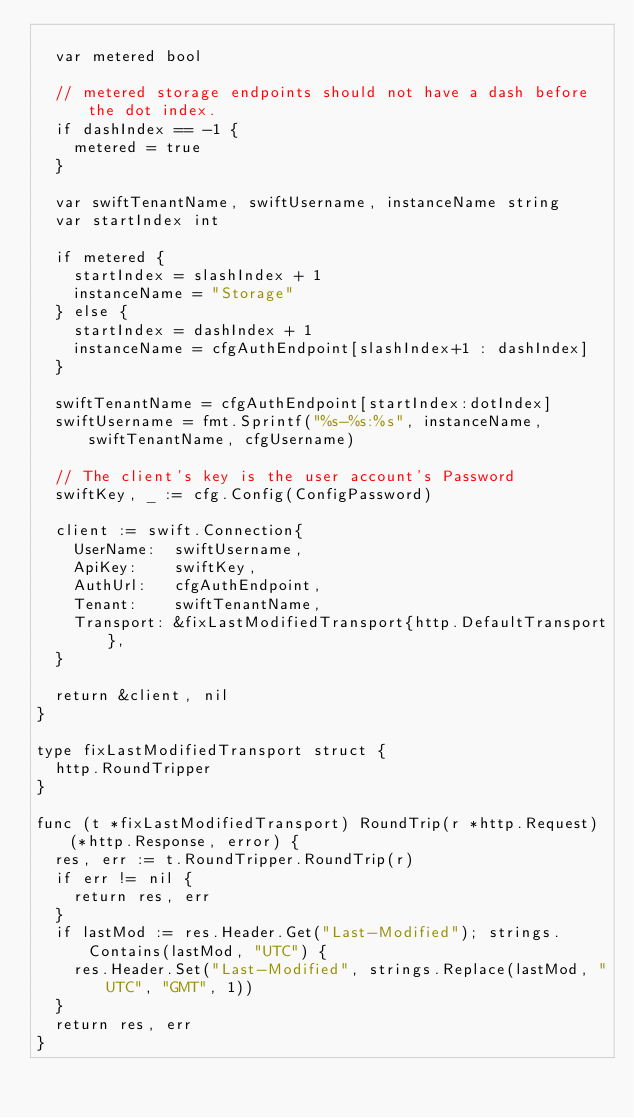Convert code to text. <code><loc_0><loc_0><loc_500><loc_500><_Go_>
	var metered bool

	// metered storage endpoints should not have a dash before the dot index.
	if dashIndex == -1 {
		metered = true
	}

	var swiftTenantName, swiftUsername, instanceName string
	var startIndex int

	if metered {
		startIndex = slashIndex + 1
		instanceName = "Storage"
	} else {
		startIndex = dashIndex + 1
		instanceName = cfgAuthEndpoint[slashIndex+1 : dashIndex]
	}

	swiftTenantName = cfgAuthEndpoint[startIndex:dotIndex]
	swiftUsername = fmt.Sprintf("%s-%s:%s", instanceName, swiftTenantName, cfgUsername)

	// The client's key is the user account's Password
	swiftKey, _ := cfg.Config(ConfigPassword)

	client := swift.Connection{
		UserName:  swiftUsername,
		ApiKey:    swiftKey,
		AuthUrl:   cfgAuthEndpoint,
		Tenant:    swiftTenantName,
		Transport: &fixLastModifiedTransport{http.DefaultTransport},
	}

	return &client, nil
}

type fixLastModifiedTransport struct {
	http.RoundTripper
}

func (t *fixLastModifiedTransport) RoundTrip(r *http.Request) (*http.Response, error) {
	res, err := t.RoundTripper.RoundTrip(r)
	if err != nil {
		return res, err
	}
	if lastMod := res.Header.Get("Last-Modified"); strings.Contains(lastMod, "UTC") {
		res.Header.Set("Last-Modified", strings.Replace(lastMod, "UTC", "GMT", 1))
	}
	return res, err
}
</code> 